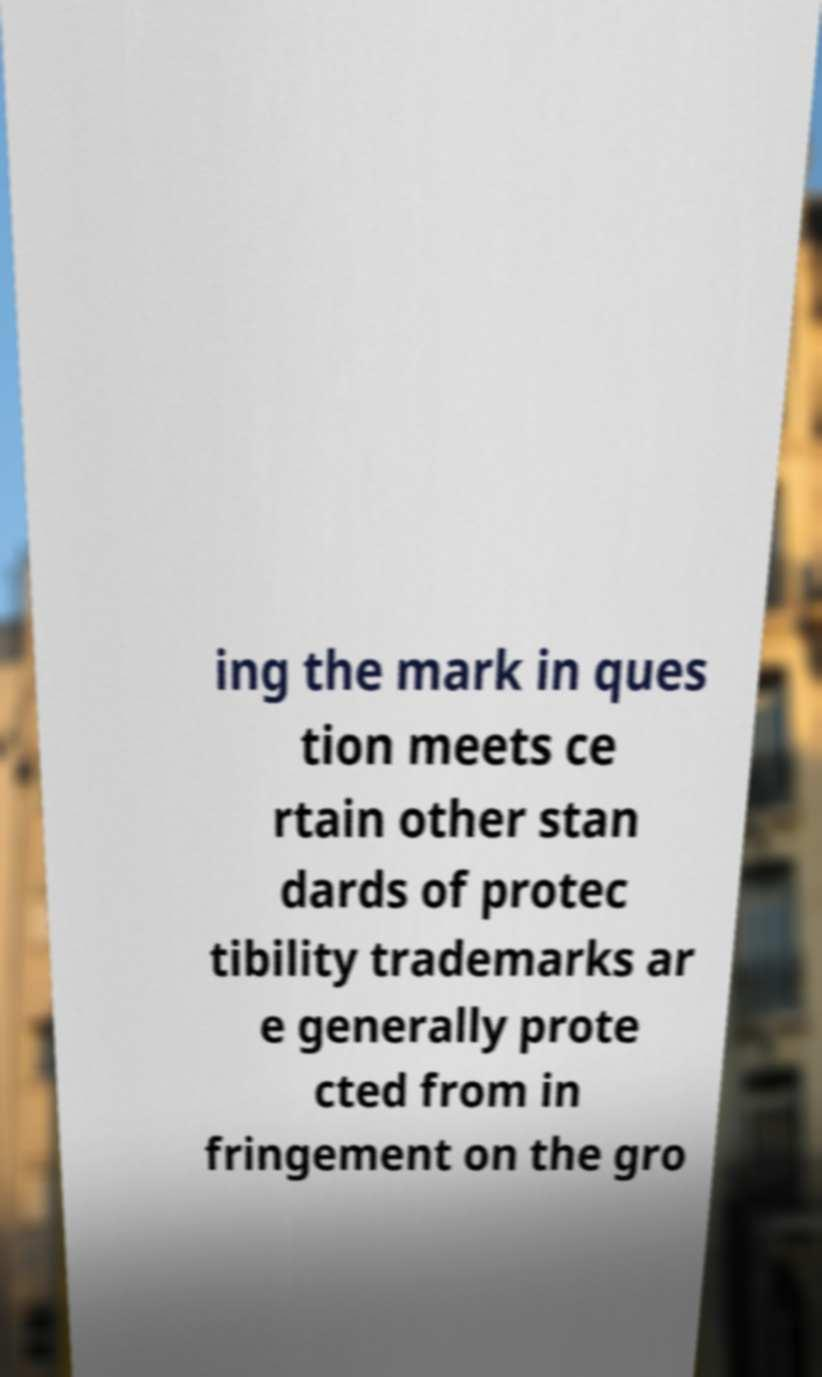Please identify and transcribe the text found in this image. ing the mark in ques tion meets ce rtain other stan dards of protec tibility trademarks ar e generally prote cted from in fringement on the gro 